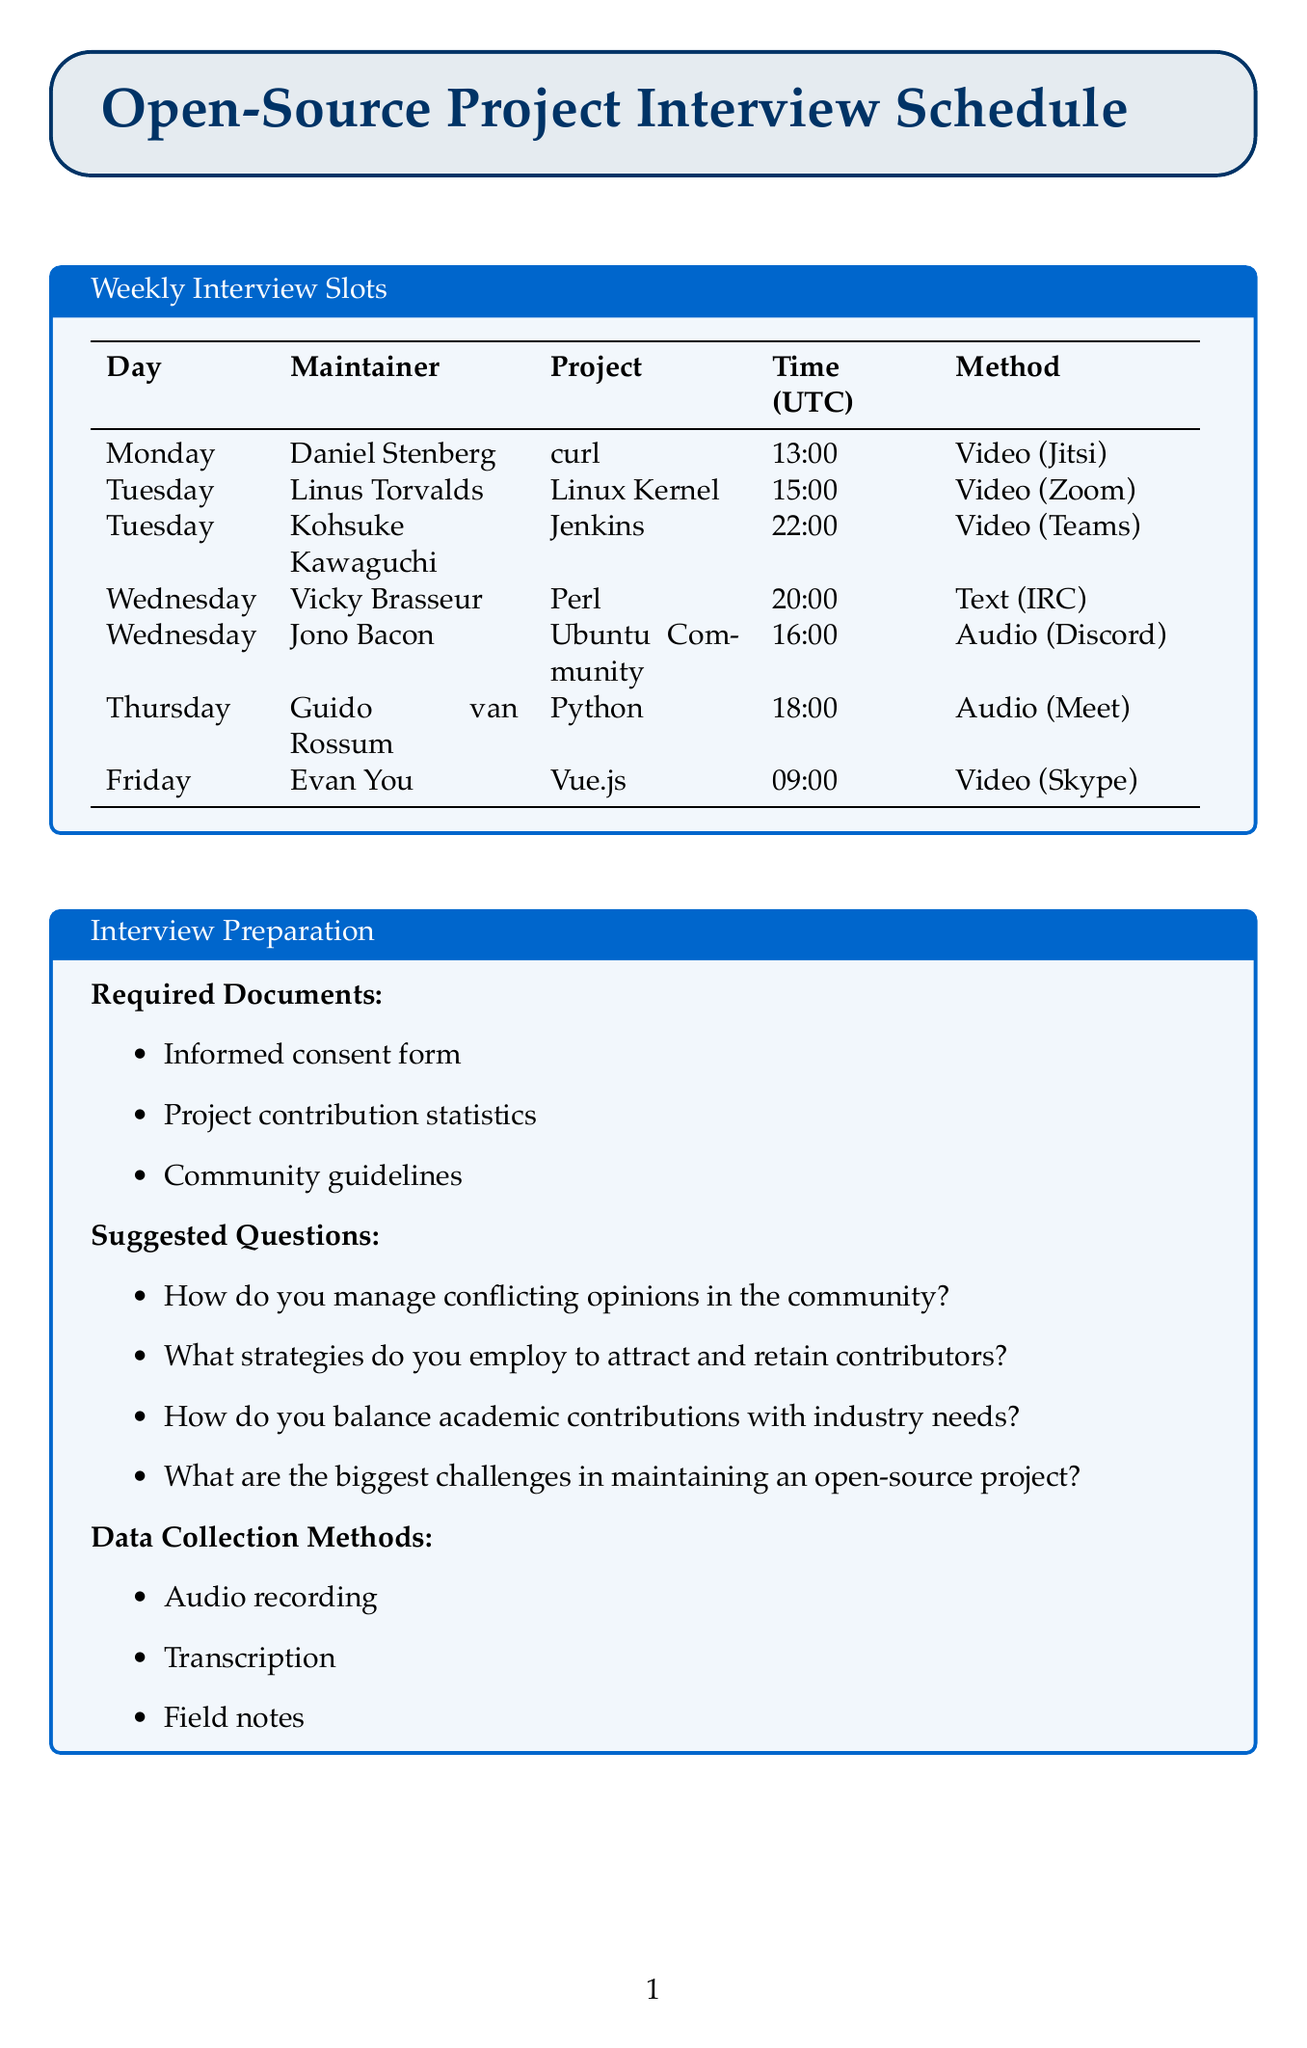What is the email address of Linus Torvalds? The email address is listed under Linus Torvalds in the interview schedule.
Answer: torvalds@linux-foundation.org What is the preferred communication method for Guido van Rossum? The preferred communication method is specified in the section for Guido van Rossum.
Answer: Audio call (Google Meet) Which project does Vicky Brasseur maintain? The project is stated alongside Vicky Brasseur's name in the document.
Answer: Perl What day does Evan You prefer for the interview? The preferred day for the interview is clearly mentioned next to Evan You's details.
Answer: Friday How many maintainers are scheduled for interviews on Wednesday? The number of maintainers is counted from the schedule presented.
Answer: 2 What is the time slot for Daniel Stenberg's interview? The time slot is shown next to Daniel Stenberg's name in the interview schedule.
Answer: 13:00 UTC Which communication method does Kohsuke Kawaguchi prefer? The document specifies Kohsuke Kawaguchi's preferred communication method.
Answer: Video call (Microsoft Teams) What is one of the suggested questions for the interviews? A suggested question is found in the Interview Preparation section of the document.
Answer: How do you manage conflicting opinions in the community? What is one of the required documents for the interview preparation? A required document is listed under the Interview Preparation section.
Answer: Informed consent form 